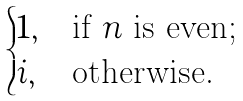<formula> <loc_0><loc_0><loc_500><loc_500>\begin{cases} 1 , & \text {if $n$ is even;} \\ i , & \text {otherwise.} \end{cases}</formula> 